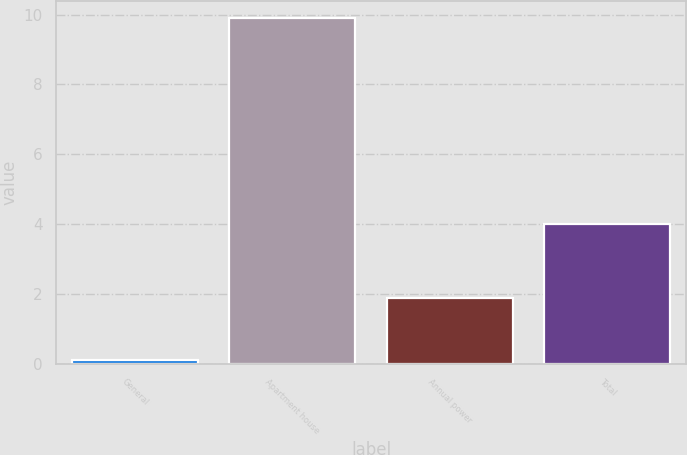<chart> <loc_0><loc_0><loc_500><loc_500><bar_chart><fcel>General<fcel>Apartment house<fcel>Annual power<fcel>Total<nl><fcel>0.1<fcel>9.9<fcel>1.9<fcel>4<nl></chart> 